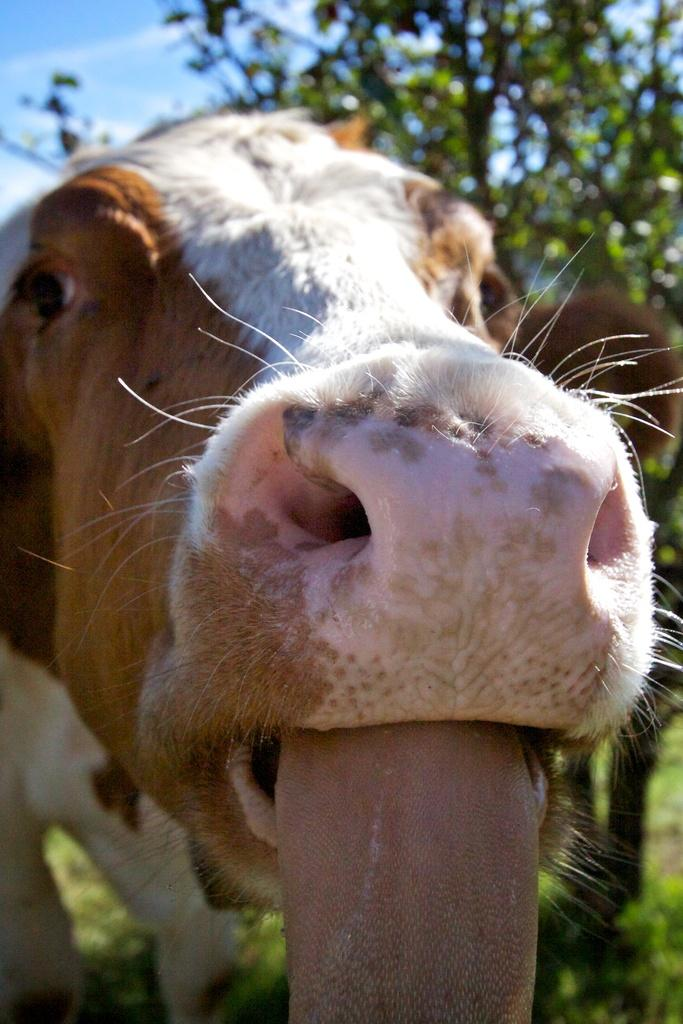What type of animal is in the picture? There is a brown and white cow in the picture. What is the cow doing in the picture? The cow is looking into the camera. What can be seen in the background of the picture? There is a tree visible in the background of the picture. What type of line can be seen on the cow's face in the image? There is no line visible on the cow's face in the image. What need does the cow have in the image? The cow does not have any specific need depicted in the image. 